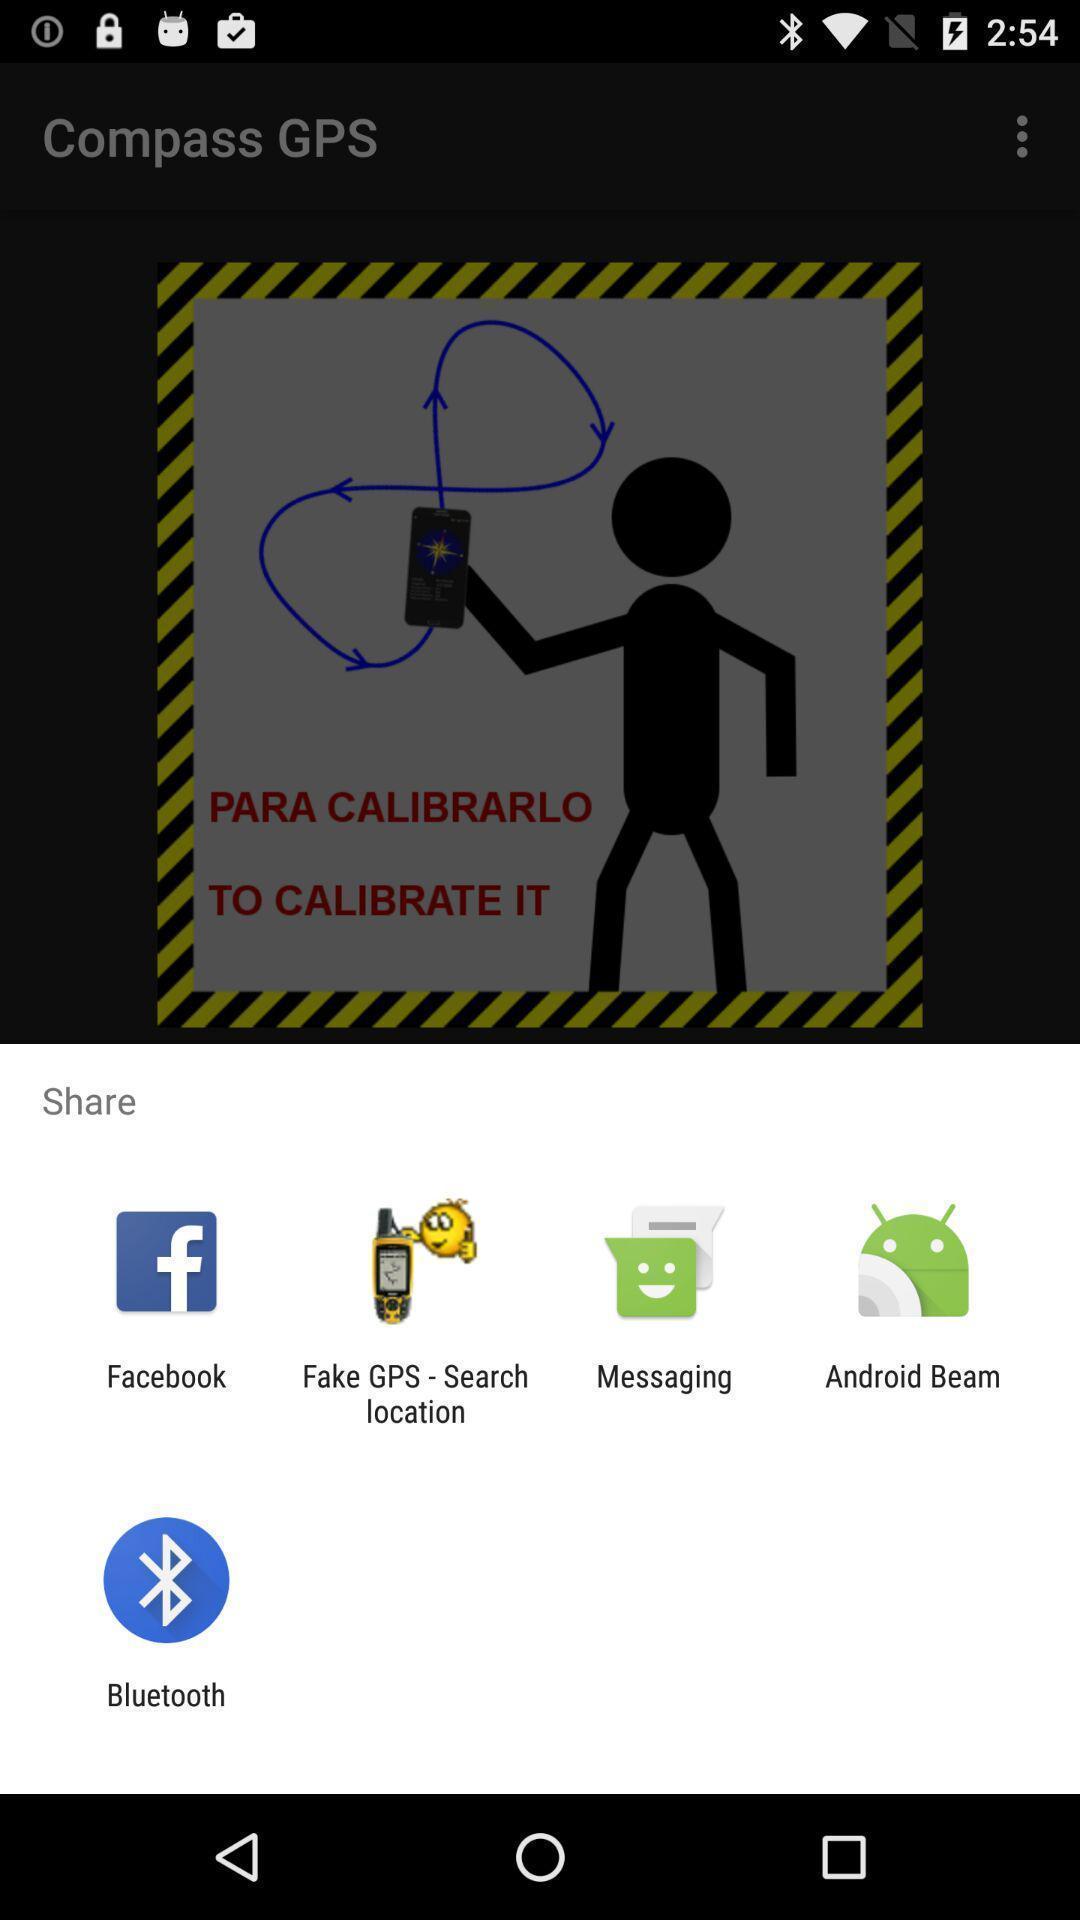Give me a summary of this screen capture. Push up message for sharing data via social network. 